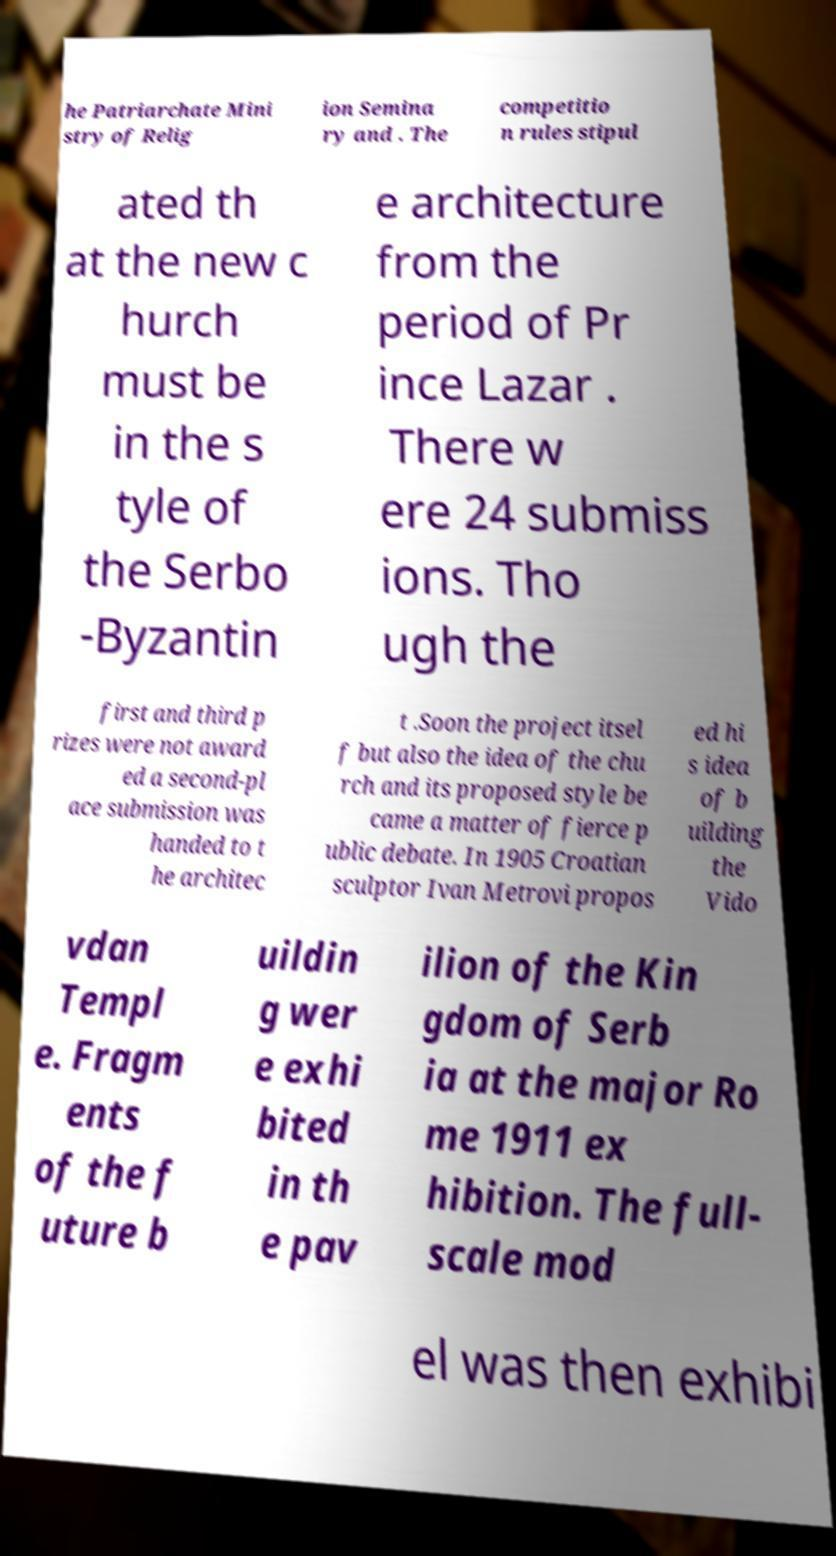Please read and relay the text visible in this image. What does it say? he Patriarchate Mini stry of Relig ion Semina ry and . The competitio n rules stipul ated th at the new c hurch must be in the s tyle of the Serbo -Byzantin e architecture from the period of Pr ince Lazar . There w ere 24 submiss ions. Tho ugh the first and third p rizes were not award ed a second-pl ace submission was handed to t he architec t .Soon the project itsel f but also the idea of the chu rch and its proposed style be came a matter of fierce p ublic debate. In 1905 Croatian sculptor Ivan Metrovi propos ed hi s idea of b uilding the Vido vdan Templ e. Fragm ents of the f uture b uildin g wer e exhi bited in th e pav ilion of the Kin gdom of Serb ia at the major Ro me 1911 ex hibition. The full- scale mod el was then exhibi 